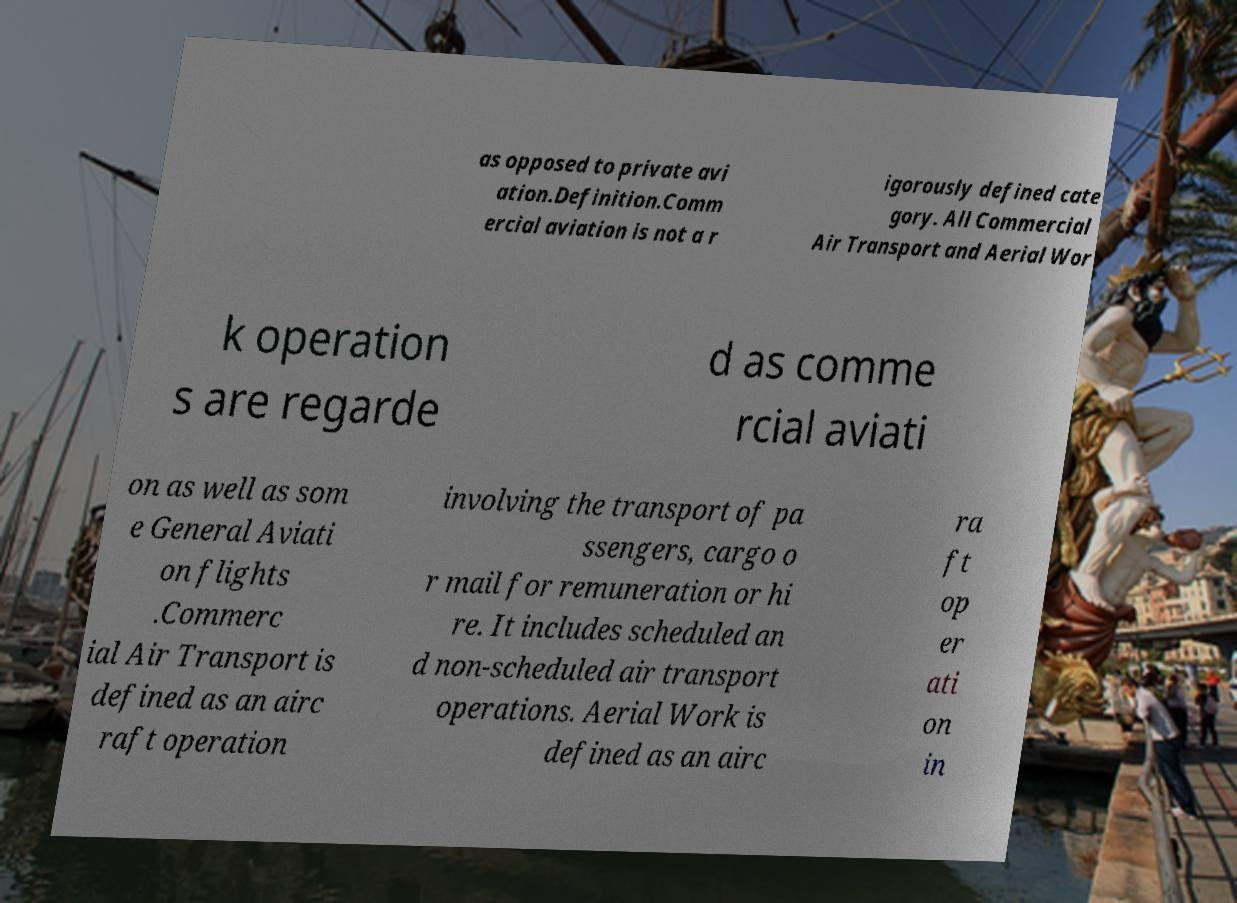Can you accurately transcribe the text from the provided image for me? as opposed to private avi ation.Definition.Comm ercial aviation is not a r igorously defined cate gory. All Commercial Air Transport and Aerial Wor k operation s are regarde d as comme rcial aviati on as well as som e General Aviati on flights .Commerc ial Air Transport is defined as an airc raft operation involving the transport of pa ssengers, cargo o r mail for remuneration or hi re. It includes scheduled an d non-scheduled air transport operations. Aerial Work is defined as an airc ra ft op er ati on in 